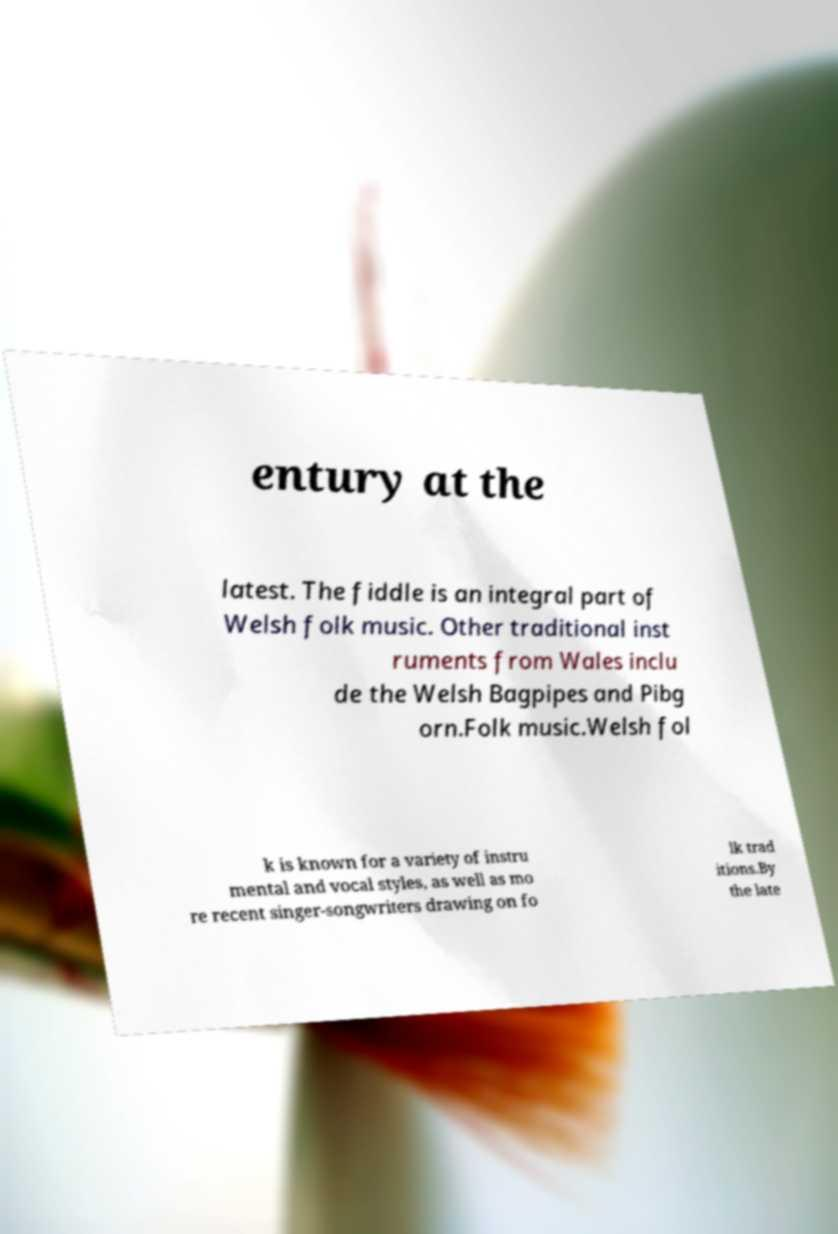I need the written content from this picture converted into text. Can you do that? entury at the latest. The fiddle is an integral part of Welsh folk music. Other traditional inst ruments from Wales inclu de the Welsh Bagpipes and Pibg orn.Folk music.Welsh fol k is known for a variety of instru mental and vocal styles, as well as mo re recent singer-songwriters drawing on fo lk trad itions.By the late 